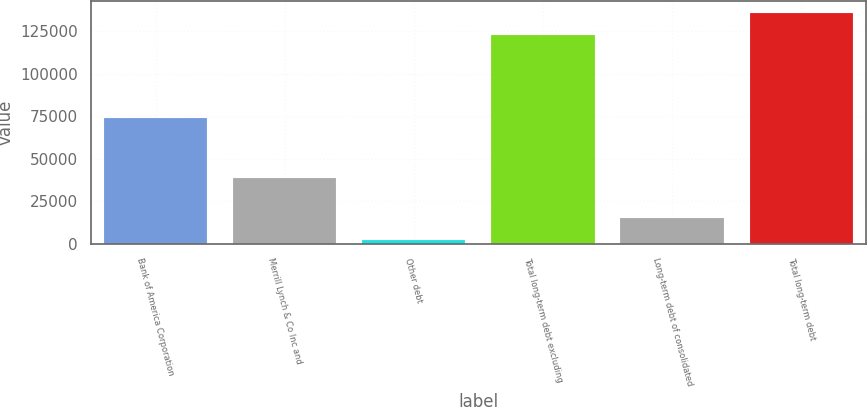<chart> <loc_0><loc_0><loc_500><loc_500><bar_chart><fcel>Bank of America Corporation<fcel>Merrill Lynch & Co Inc and<fcel>Other debt<fcel>Total long-term debt excluding<fcel>Long-term debt of consolidated<fcel>Total long-term debt<nl><fcel>73940<fcel>38954<fcel>2122<fcel>122944<fcel>15178.4<fcel>136000<nl></chart> 